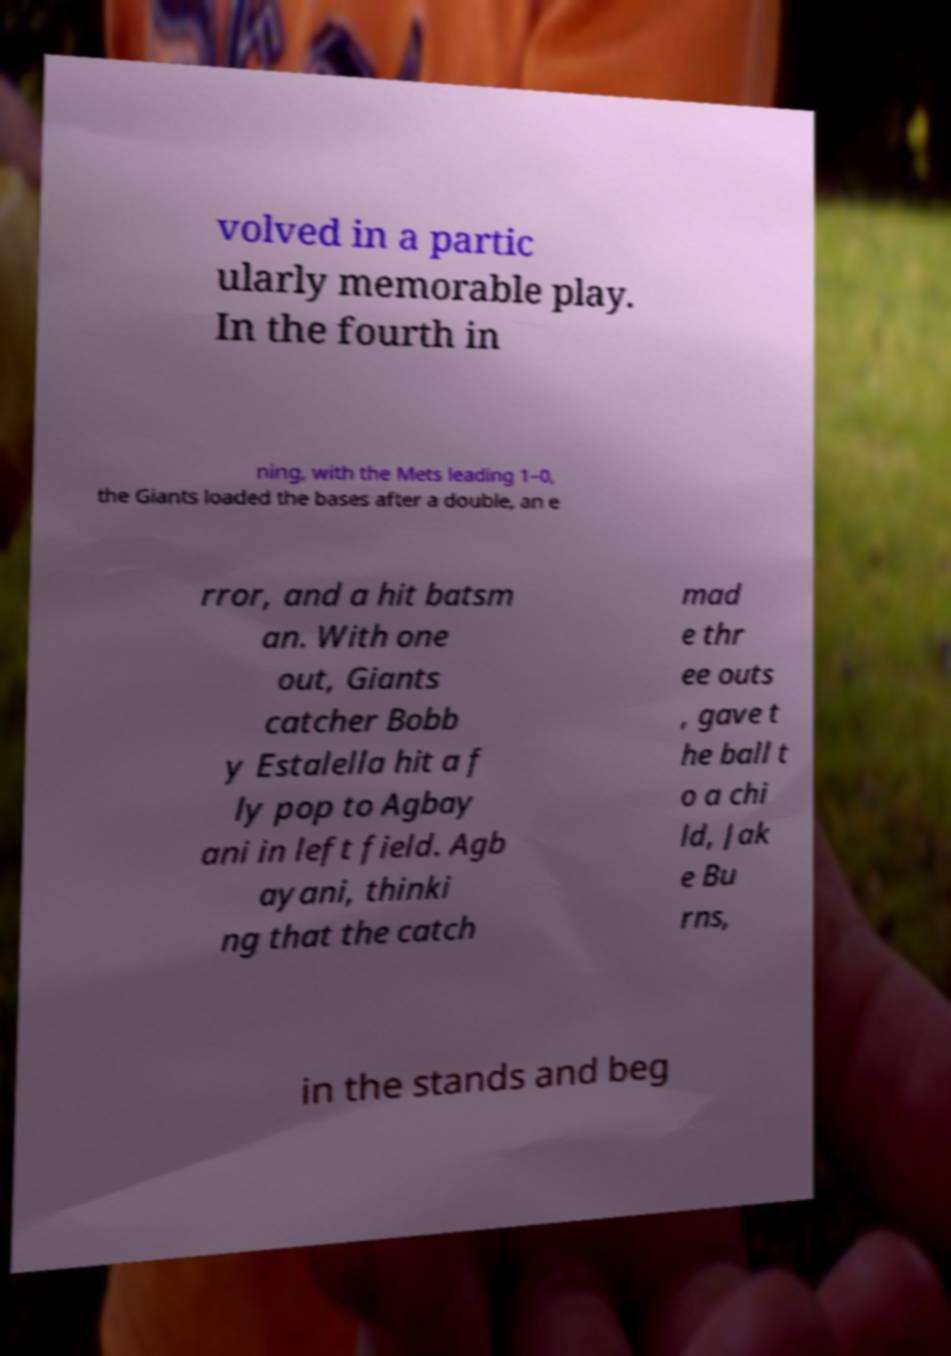What messages or text are displayed in this image? I need them in a readable, typed format. volved in a partic ularly memorable play. In the fourth in ning, with the Mets leading 1–0, the Giants loaded the bases after a double, an e rror, and a hit batsm an. With one out, Giants catcher Bobb y Estalella hit a f ly pop to Agbay ani in left field. Agb ayani, thinki ng that the catch mad e thr ee outs , gave t he ball t o a chi ld, Jak e Bu rns, in the stands and beg 